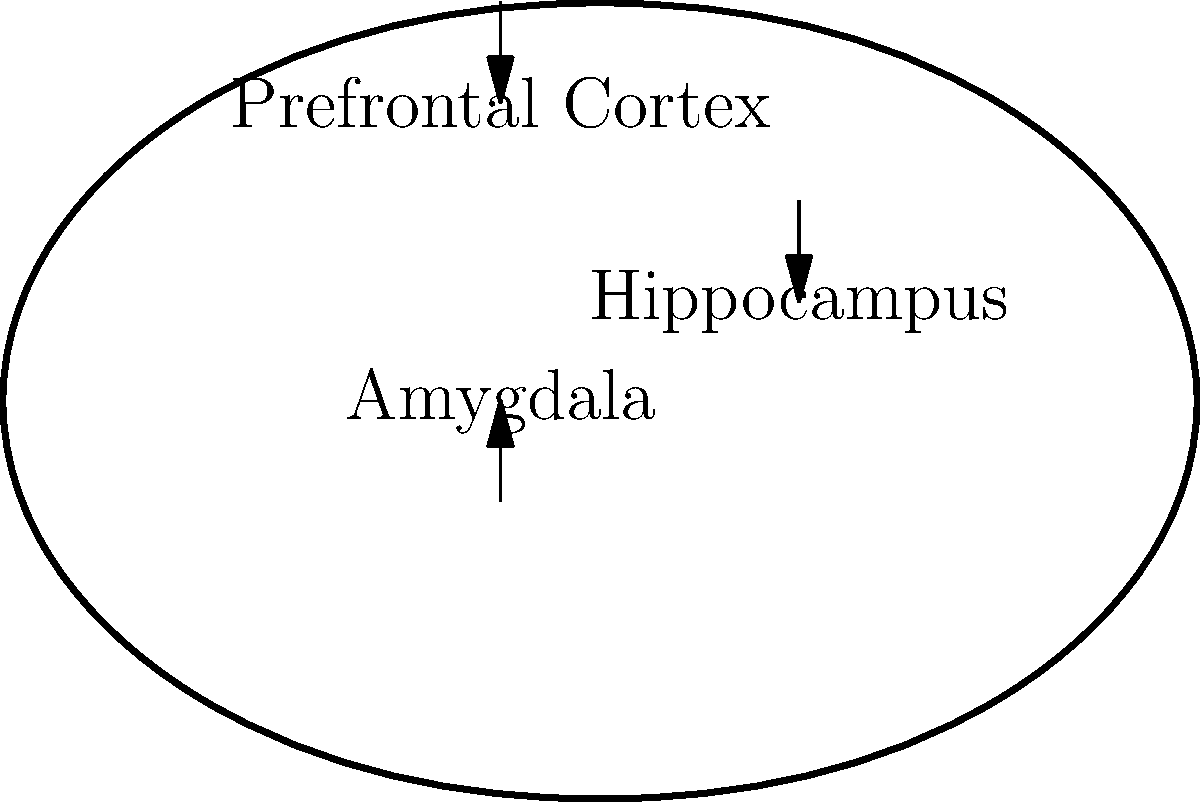In the context of trauma from domestic abuse, which part of the brain labeled in the diagram is primarily responsible for the heightened fear response and emotional reactivity often observed in survivors? To answer this question, let's consider the roles of the labeled brain structures in relation to trauma:

1. Prefrontal Cortex: This area is responsible for executive functions, decision-making, and regulating emotions. While it can be affected by trauma, it's not primarily responsible for the fear response.

2. Hippocampus: This structure is crucial for memory formation and consolidation. Trauma can impact the hippocampus, leading to fragmented memories, but it's not the primary source of fear responses.

3. Amygdala: This almond-shaped structure is central to processing emotions, particularly fear and threat detection. In trauma survivors, the amygdala often becomes hyperactive, leading to:
   a) Increased sensitivity to potential threats
   b) Heightened emotional responses
   c) Persistent feelings of fear or anxiety

The amygdala's overactivity in trauma survivors explains the exaggerated startle responses, hypervigilance, and intense emotional reactions often observed in those who have experienced domestic abuse.

Therefore, among the labeled structures, the amygdala is primarily responsible for the heightened fear response and emotional reactivity in trauma survivors.
Answer: Amygdala 